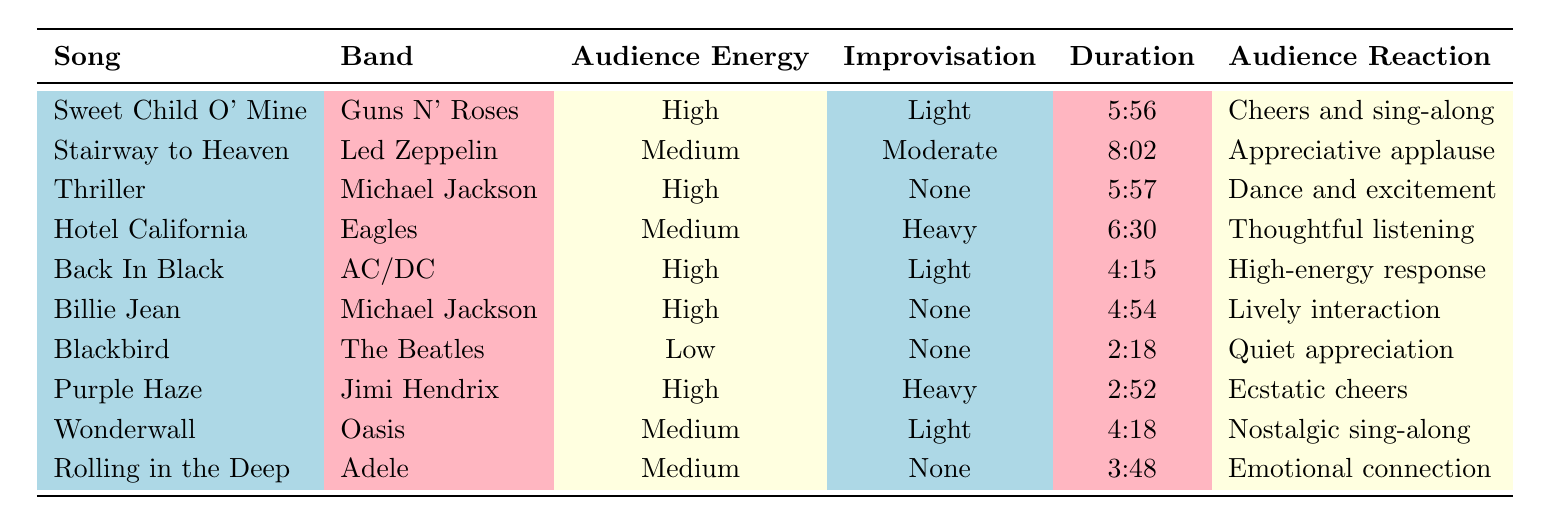What is the audience reaction for "Stairway to Heaven"? The table shows that the audience reaction for "Stairway to Heaven" is "appreciative applause." This information is directly retrievable from the corresponding row of the table.
Answer: Appreciative applause Which song has the highest audience energy? From the table, there are three songs categorized under "high" for audience energy: "Sweet Child O' Mine," "Thriller," "Back In Black," and "Billie Jean," as well as "Purple Haze." All these songs share the highest audience energy.
Answer: Sweet Child O' Mine, Thriller, Back In Black, Billie Jean, Purple Haze What is the average duration of the songs with "medium" audience energy? The songs with "medium" audience energy are "Stairway to Heaven" (8:02), "Hotel California" (6:30), "Wonderwall" (4:18), and "Rolling in the Deep" (3:48). Converting these durations into total seconds: 482 + 390 + 258 + 228 = 1358 seconds. There are 4 songs, so the average duration is 1358/4 = 339.5 seconds. Converting back to MM:SS gives approximately 5:39.5 as the average duration.
Answer: 5:39.5 Is it true that "Billie Jean" has no improvisation? The entry for "Billie Jean" in the table indicates that the improvisation is marked as "none." Therefore, the statement is accurate based on the data displayed.
Answer: Yes How many songs have “heavy” improvisation? The only song listed with "heavy" improvisation in the table is "Purple Haze." By examining the "Improvisation" column, we find that this song stands out for this characteristic.
Answer: 1 